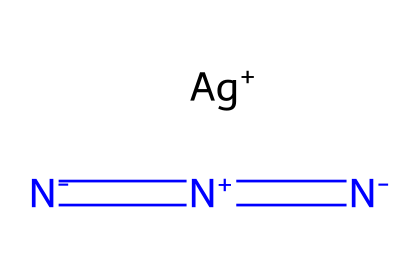What is the name of this chemical? The chemical structure provided indicates the presence of silver (Ag) and azide (N3), which together form silver azide.
Answer: silver azide How many nitrogen atoms are present in this compound? The chemical structure shows three nitrogen atoms that are part of the azide group, connected by double bonds and a lone nitrogen, totaling three nitrogen atoms.
Answer: three What is the charge of the silver ion in this compound? In the SMILES representation, silver (Ag) is shown as a positively charged ion ([Ag+]), indicating its charge as +1.
Answer: +1 Is silver azide a primary explosive? Silver azide is known to be extremely sensitive and is classified as a primary explosive due to its ability to detonate easily under shock or friction.
Answer: yes How many total bonds are present in the azide group of silver azide? The azide group consists of three nitrogen atoms bonded in a linear arrangement, with a total of two double bonds, resulting in a total of three bonds in the azide group.
Answer: two Why is silver azide used in the mining and construction industries? Silver azide is utilized in these industries primarily because of its high sensitivity as a primary explosive, allowing it to be used in applications where precise detonations are required.
Answer: high sensitivity What makes silver azide distinct from other azides? Silver azide is distinct among azides due to its heavy metal component (silver), which introduces unique properties in terms of sensitivity and stability compared to organic azides.
Answer: heavy metal component 